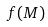<formula> <loc_0><loc_0><loc_500><loc_500>f ( M )</formula> 